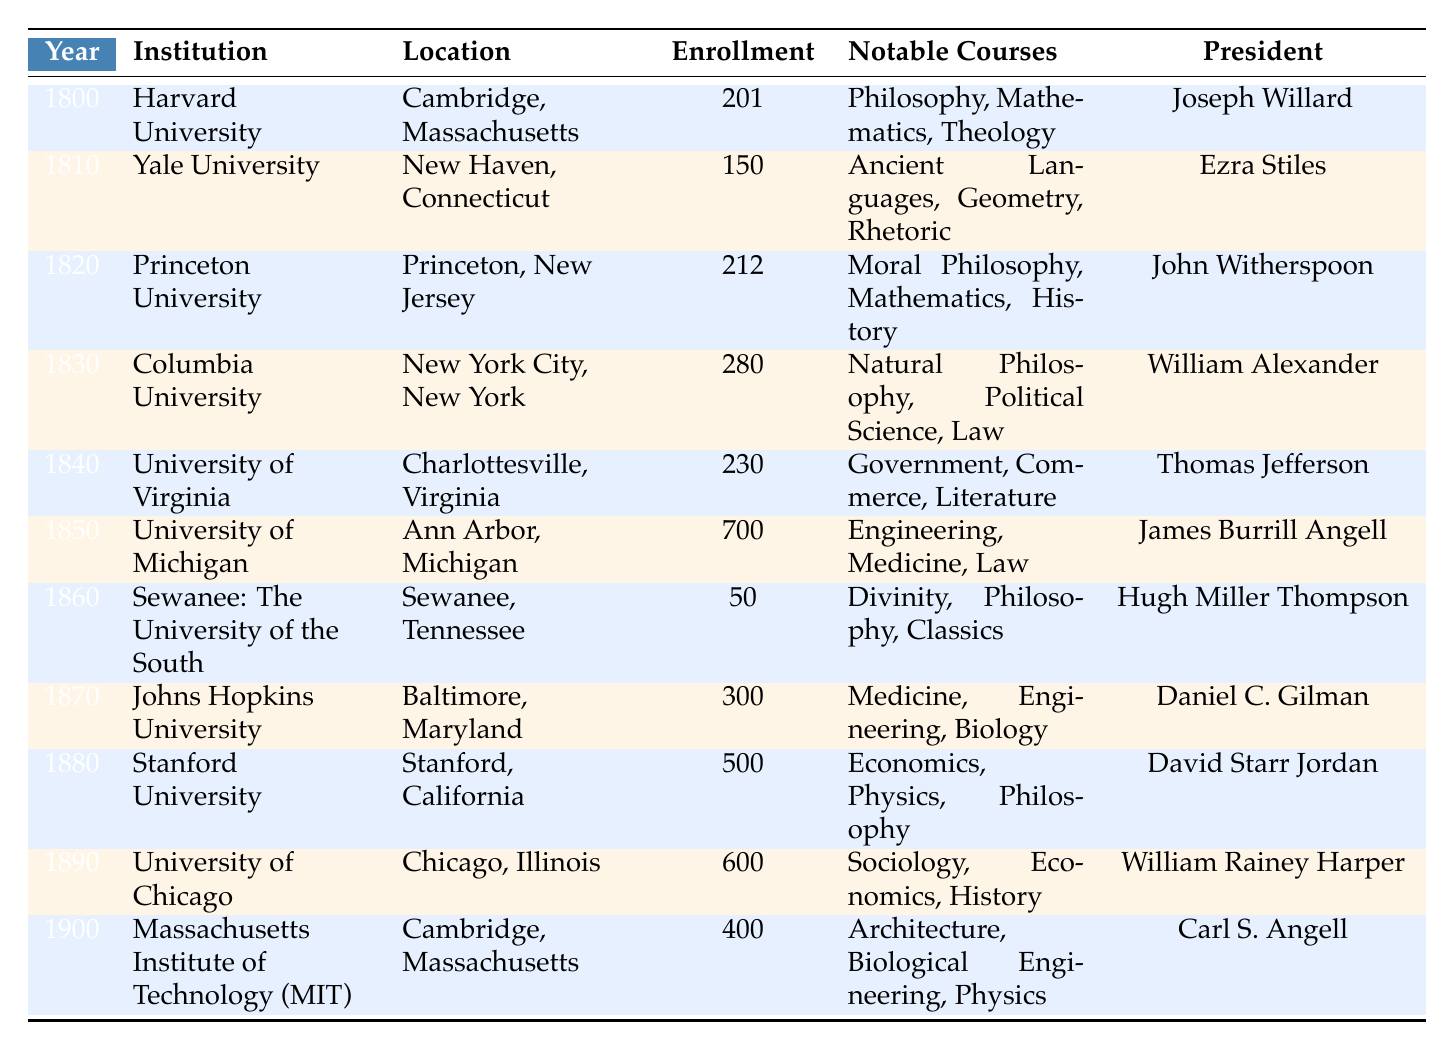What institution had the highest enrollment in 1850? The table shows that the University of Michigan had an enrollment of 700 in 1850, which is the highest number listed for that year.
Answer: University of Michigan Which president led Harvard University in 1800? According to the table, the president of Harvard University in 1800 was Joseph Willard.
Answer: Joseph Willard What year did the University of Chicago enroll 600 students? The table indicates that the University of Chicago had an enrollment of 600 students in 1890.
Answer: 1890 How many institutions had an enrollment greater than 400 students? The table shows that three institutions had enrollments greater than 400 students: University of Michigan (700), Stanford University (500), and University of Chicago (600). This counts to a total of 3 institutions.
Answer: 3 What was the notable course at Sewanee in 1860? The table lists Divinity as one of the notable courses at Sewanee: The University of the South in 1860.
Answer: Divinity What is the sum of enrollments for the years 1800 and 1810? The enrollment for Harvard University in 1800 was 201, and for Yale University in 1810, it was 150. Summing these gives 201 + 150 = 351.
Answer: 351 Was Thomas Jefferson the president of the University of Virginia in 1840? The table states that Thomas Jefferson was indeed the president of the University of Virginia in 1840. Thus, the statement is true.
Answer: Yes Which institution had the lowest enrollment and what was the figure? The table shows that Sewanee: The University of the South had the lowest enrollment with 50 students in 1860.
Answer: Sewanee: The University of the South, 50 What notable courses were offered at Johns Hopkins University in 1870? The table lists the notable courses at Johns Hopkins University in 1870 as Medicine, Engineering, and Biology.
Answer: Medicine, Engineering, Biology Calculate the average enrollment of all institutions listed for the year 1900. The table shows two institutions for 1900, with MIT at 400 and total enrollment of 400. For one institution, 400/1 = 400 is the average.
Answer: 400 How did enrollment change from 1860 to 1870? The enrollment at Sewanee in 1860 was 50, and at Johns Hopkins in 1870 was 300. The change is 300 - 50 = 250, indicating an increase.
Answer: Increased by 250 